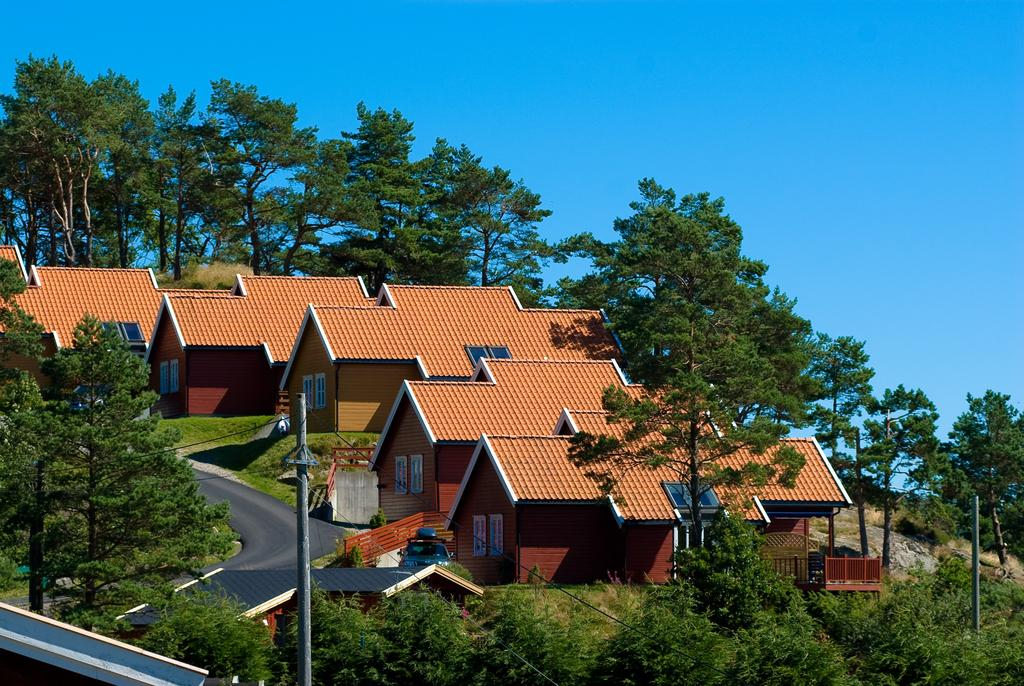What type of natural elements can be seen in the image? There are trees in the image. What type of man-made structures are present in the image? There are houses in the image. What type of infrastructure can be seen in the image? There are poles and wires in the image. What type of transportation route is visible in the image? There is a road in the image. What is visible in the background of the image? The sky is visible in the background of the image. What type of health advice can be seen on the edge of the image? There is no health advice or edge present in the image; it features trees, houses, poles, wires, a road, and the sky. How does the image convey respect for the environment? The image itself does not convey respect for the environment; it is a visual representation of the scene. However, the presence of trees and a road suggests that the environment is being utilized for both natural and urban purposes. 